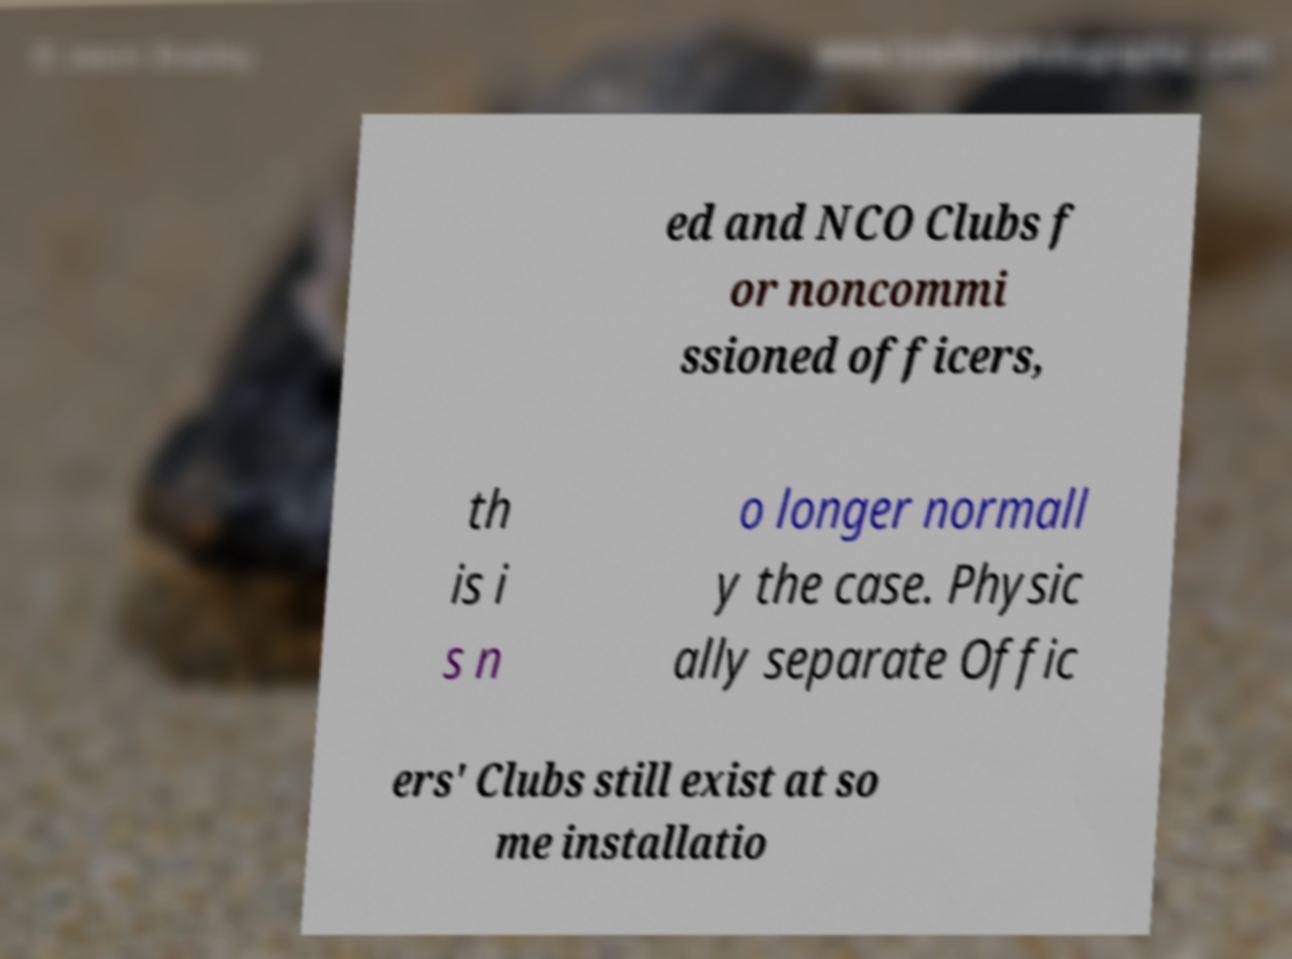Please read and relay the text visible in this image. What does it say? ed and NCO Clubs f or noncommi ssioned officers, th is i s n o longer normall y the case. Physic ally separate Offic ers' Clubs still exist at so me installatio 